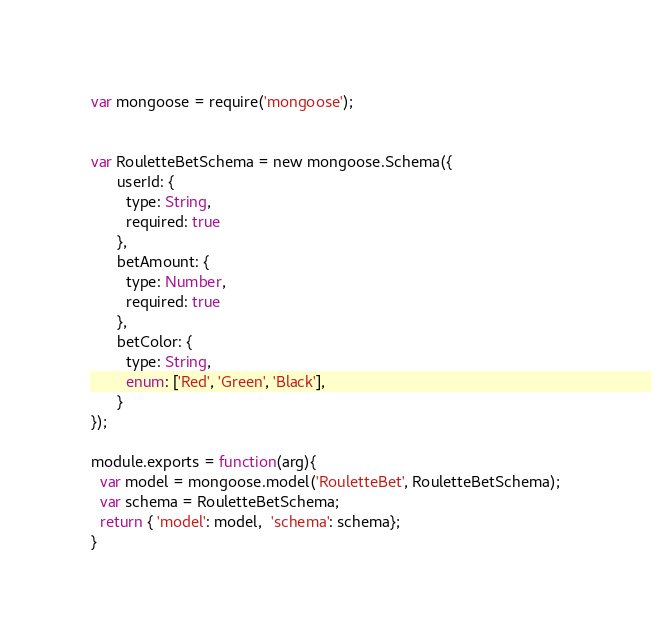Convert code to text. <code><loc_0><loc_0><loc_500><loc_500><_JavaScript_>var mongoose = require('mongoose');


var RouletteBetSchema = new mongoose.Schema({
      userId: {
        type: String,
        required: true
      },
      betAmount: {
        type: Number,
        required: true
      },
      betColor: {
        type: String,
        enum: ['Red', 'Green', 'Black'],
      }
});

module.exports = function(arg){
  var model = mongoose.model('RouletteBet', RouletteBetSchema);
  var schema = RouletteBetSchema;
  return { 'model': model,  'schema': schema};
}
</code> 